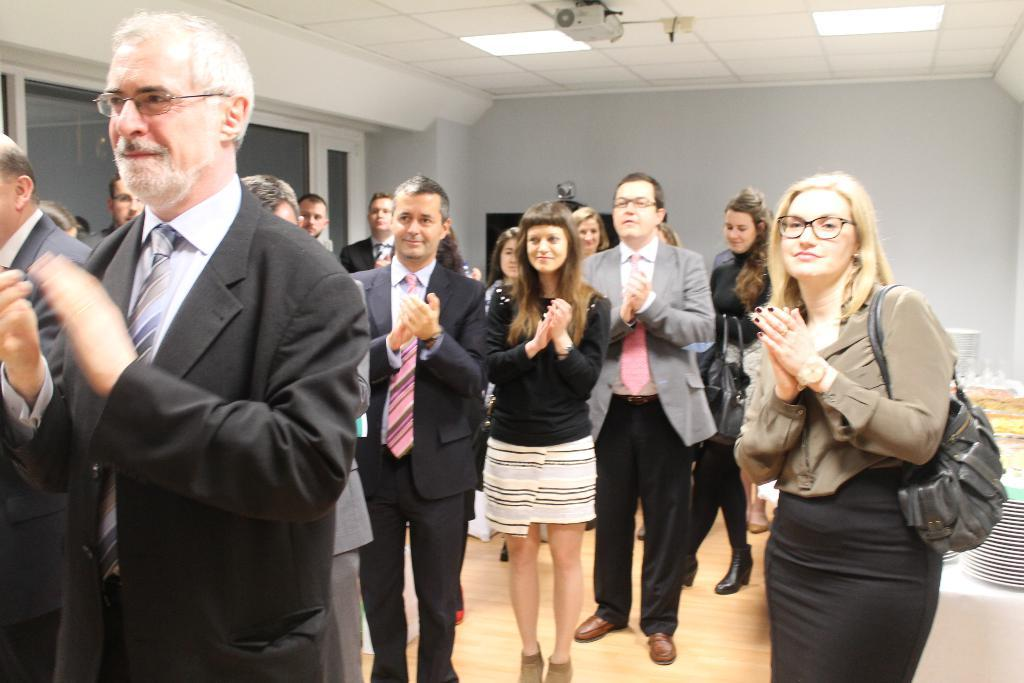How many people are in the image? There are people in the image, but the exact number is not specified. What are the people doing in the image? The people are clapping their hands in the image. Can you describe the woman's attire in the image? The woman is wearing a bag in the image. What device is present in the image for displaying visuals? There is a projector in the image. What is located near the projector in the image? There are lights beside the projector in the image. What objects can be seen on a table in the image? There are plates and objects on a table in the image. What type of juice is being served in the image? There is no mention of juice in the image; it does not appear to be present. 